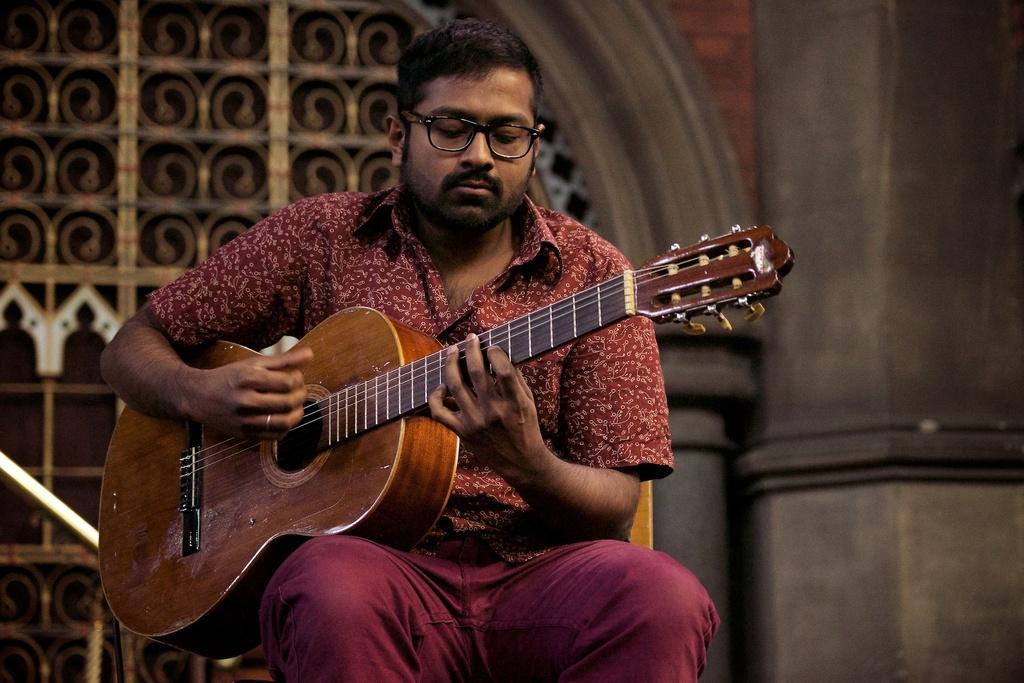How would you summarize this image in a sentence or two? This image consists of a man who is wearing brown color dress. He is holding a guitar in his hands. He is playing it. 